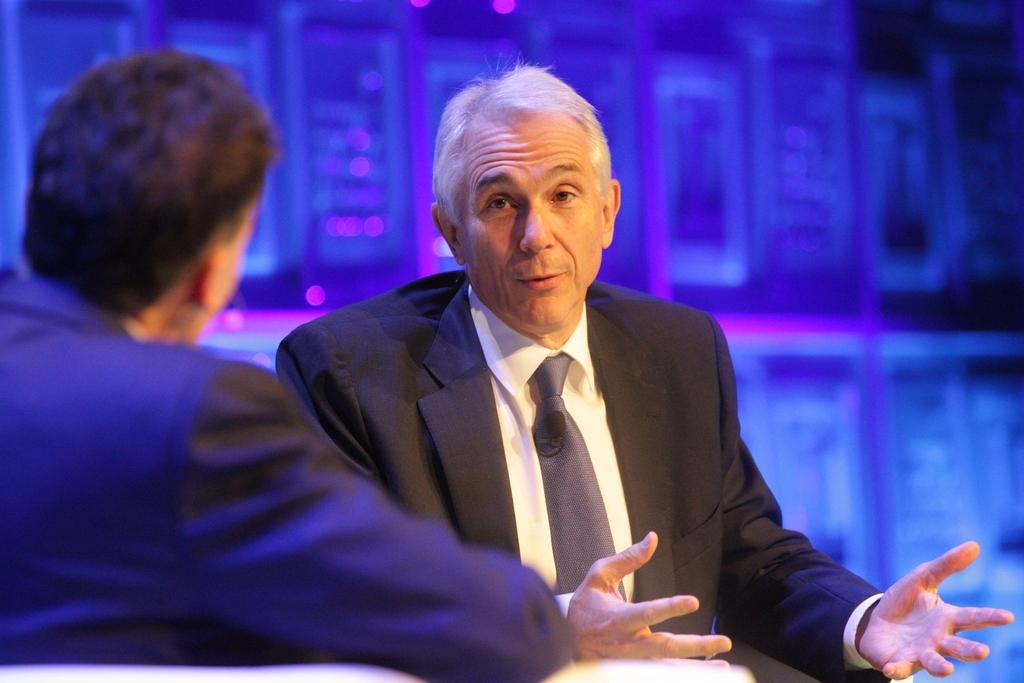How many people are present in the image? There are two people in the image. What are the two people doing? One person is talking, and the other person is listening. Can you describe the background of the image? The background of the image is blue and pink. What type of door can be seen in the image? There is no door present in the image. How does the heat affect the people in the image? There is no mention of heat in the image, so it cannot be determined how it affects the people. 